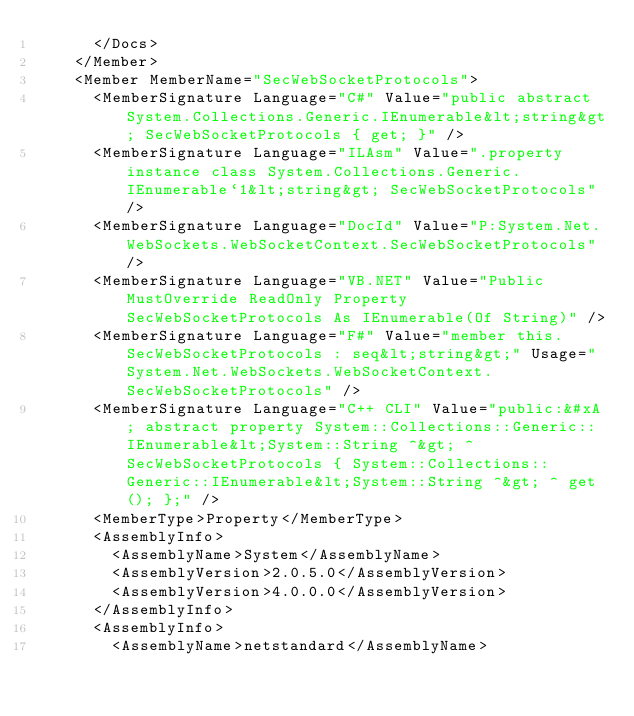Convert code to text. <code><loc_0><loc_0><loc_500><loc_500><_XML_>      </Docs>
    </Member>
    <Member MemberName="SecWebSocketProtocols">
      <MemberSignature Language="C#" Value="public abstract System.Collections.Generic.IEnumerable&lt;string&gt; SecWebSocketProtocols { get; }" />
      <MemberSignature Language="ILAsm" Value=".property instance class System.Collections.Generic.IEnumerable`1&lt;string&gt; SecWebSocketProtocols" />
      <MemberSignature Language="DocId" Value="P:System.Net.WebSockets.WebSocketContext.SecWebSocketProtocols" />
      <MemberSignature Language="VB.NET" Value="Public MustOverride ReadOnly Property SecWebSocketProtocols As IEnumerable(Of String)" />
      <MemberSignature Language="F#" Value="member this.SecWebSocketProtocols : seq&lt;string&gt;" Usage="System.Net.WebSockets.WebSocketContext.SecWebSocketProtocols" />
      <MemberSignature Language="C++ CLI" Value="public:&#xA; abstract property System::Collections::Generic::IEnumerable&lt;System::String ^&gt; ^ SecWebSocketProtocols { System::Collections::Generic::IEnumerable&lt;System::String ^&gt; ^ get(); };" />
      <MemberType>Property</MemberType>
      <AssemblyInfo>
        <AssemblyName>System</AssemblyName>
        <AssemblyVersion>2.0.5.0</AssemblyVersion>
        <AssemblyVersion>4.0.0.0</AssemblyVersion>
      </AssemblyInfo>
      <AssemblyInfo>
        <AssemblyName>netstandard</AssemblyName></code> 